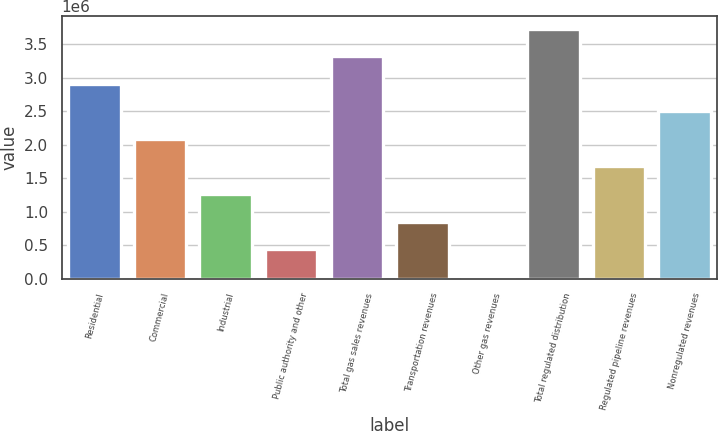Convert chart to OTSL. <chart><loc_0><loc_0><loc_500><loc_500><bar_chart><fcel>Residential<fcel>Commercial<fcel>Industrial<fcel>Public authority and other<fcel>Total gas sales revenues<fcel>Transportation revenues<fcel>Other gas revenues<fcel>Total regulated distribution<fcel>Regulated pipeline revenues<fcel>Nonregulated revenues<nl><fcel>2.90785e+06<fcel>2.08499e+06<fcel>1.26214e+06<fcel>439280<fcel>3.31928e+06<fcel>850709<fcel>27852<fcel>3.73071e+06<fcel>1.67357e+06<fcel>2.49642e+06<nl></chart> 